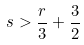Convert formula to latex. <formula><loc_0><loc_0><loc_500><loc_500>s > \frac { r } { 3 } + \frac { 3 } { 2 }</formula> 